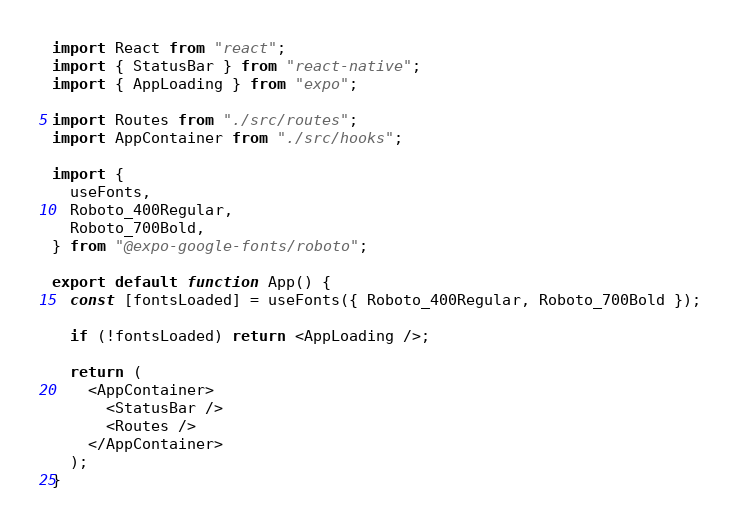<code> <loc_0><loc_0><loc_500><loc_500><_TypeScript_>import React from "react";
import { StatusBar } from "react-native";
import { AppLoading } from "expo";

import Routes from "./src/routes";
import AppContainer from "./src/hooks";

import {
  useFonts,
  Roboto_400Regular,
  Roboto_700Bold,
} from "@expo-google-fonts/roboto";

export default function App() {
  const [fontsLoaded] = useFonts({ Roboto_400Regular, Roboto_700Bold });

  if (!fontsLoaded) return <AppLoading />;

  return (
    <AppContainer>
      <StatusBar />
      <Routes />
    </AppContainer>
  );
}
</code> 